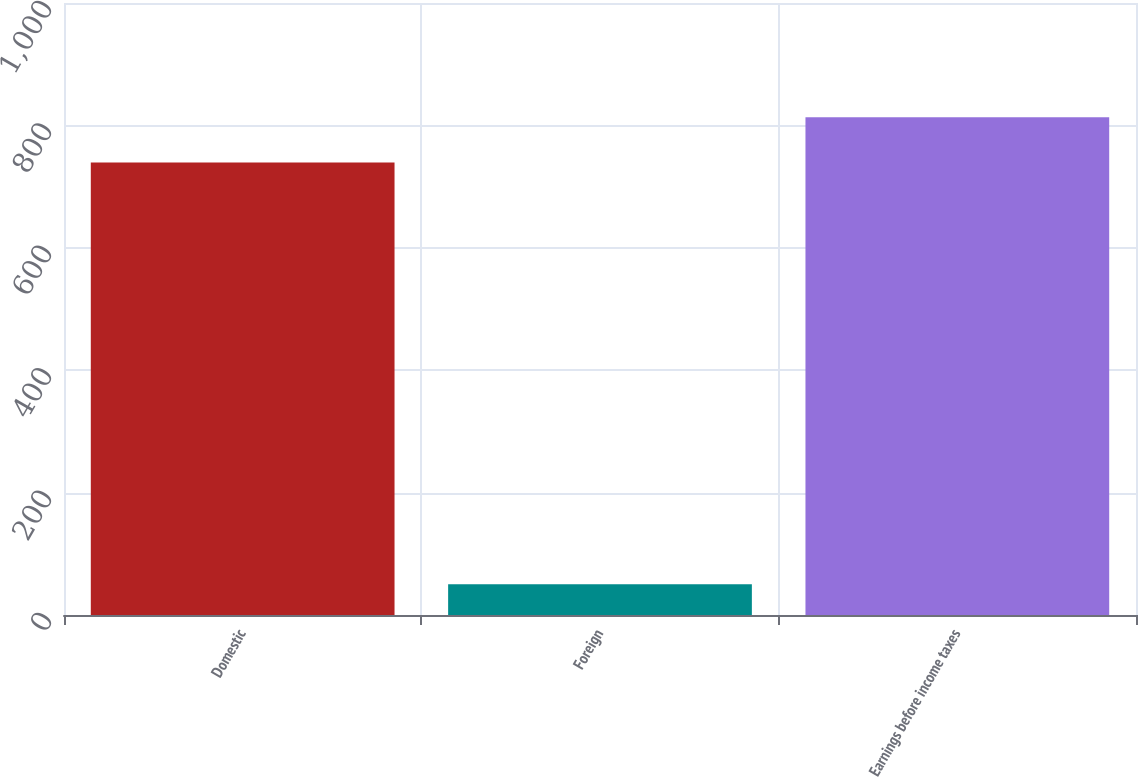<chart> <loc_0><loc_0><loc_500><loc_500><bar_chart><fcel>Domestic<fcel>Foreign<fcel>Earnings before income taxes<nl><fcel>739.4<fcel>50.3<fcel>813.34<nl></chart> 